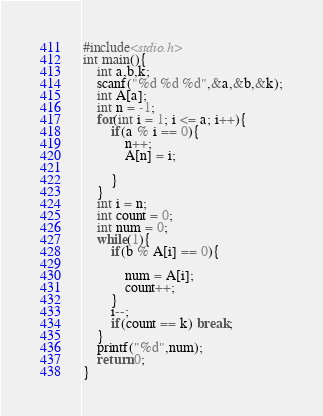<code> <loc_0><loc_0><loc_500><loc_500><_C_>#include<stdio.h>
int main(){
    int a,b,k;
    scanf("%d %d %d",&a,&b,&k);
    int A[a];
    int n = -1;
    for(int i = 1; i <= a; i++){
        if(a % i == 0){
            n++;
            A[n] = i;
            
        }
    }
    int i = n;
    int count = 0;
    int num = 0;
    while(1){
        if(b % A[i] == 0){
            
            num = A[i];
            count++;
        }
        i--;
        if(count == k) break;
    }
    printf("%d",num);
    return 0;
}</code> 